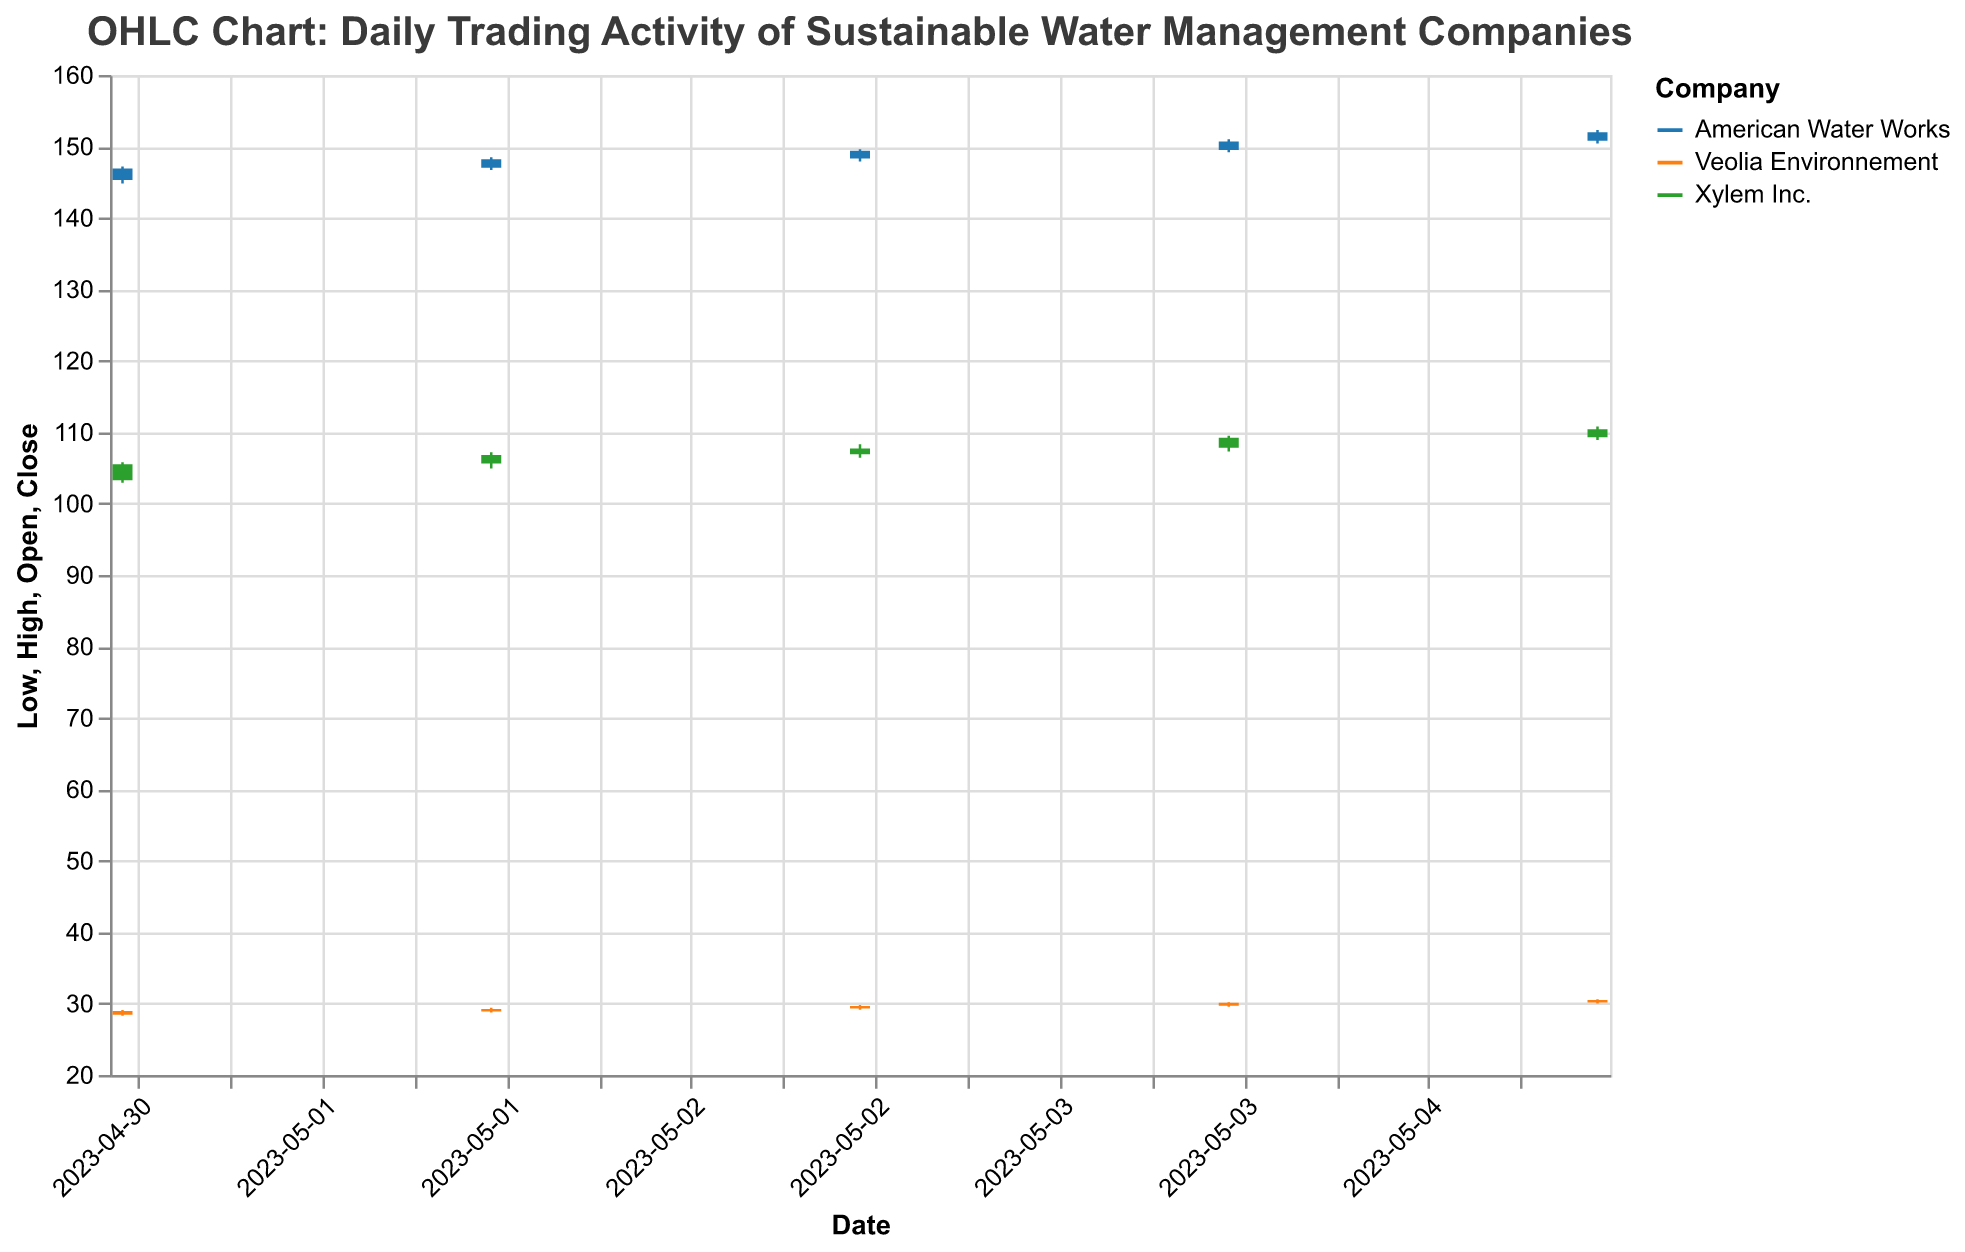What is the highest closing price for Xylem Inc. during this period? Observing the closing prices for Xylem Inc. on each date, the highest closing price is on 2023-05-05 with a value of 110.40
Answer: 110.40 Which company had the highest trading volume on 2023-05-01? Comparing the volumes for all companies on 2023-05-01, Xylem Inc. had the highest trading volume of 750,000
Answer: Xylem Inc What is the overall trend for American Water Works over the given days? By analyzing the closing prices from 2023-05-01 to 2023-05-05, we observe an upward trend: 146.90, 148.20, 149.40, 150.70, 152.00
Answer: Upward Trend Which company showed the largest increase in closing price between any two consecutive days? Veolia Environnement showed the largest increase, with its closing price rising from 29.65 on 2023-05-03 to 30.10 on 2023-05-04–an increase of 0.45
Answer: Veolia Environnement Comparing the highest price on 2023-05-04, which company had the highest high price, and what was it? On 2023-05-04, the highest price was observed for American Water Works at 151.00
Answer: American Water Works, 151.00 Which company's stock was most stable, i.e., showing the smallest range between high and low prices? By calculating the difference between high and low prices for each company over all days, we see that Veolia Environnement consistently had smaller ranges compared to the other companies
Answer: Veolia Environnement 